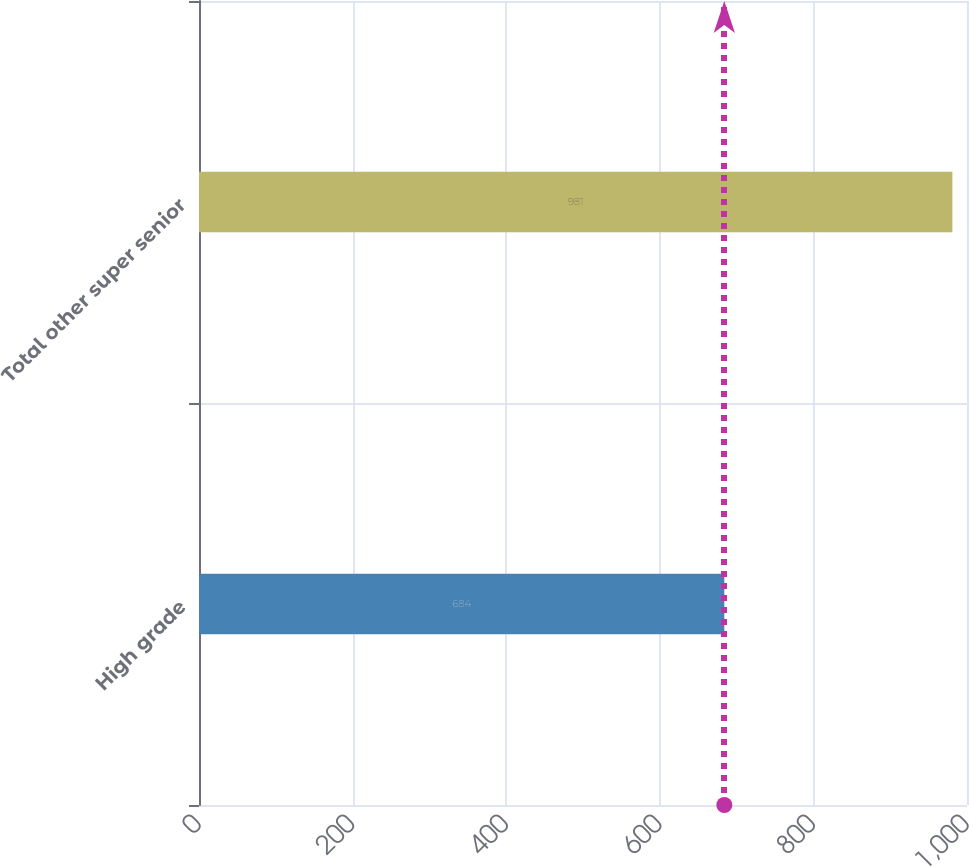Convert chart. <chart><loc_0><loc_0><loc_500><loc_500><bar_chart><fcel>High grade<fcel>Total other super senior<nl><fcel>684<fcel>981<nl></chart> 